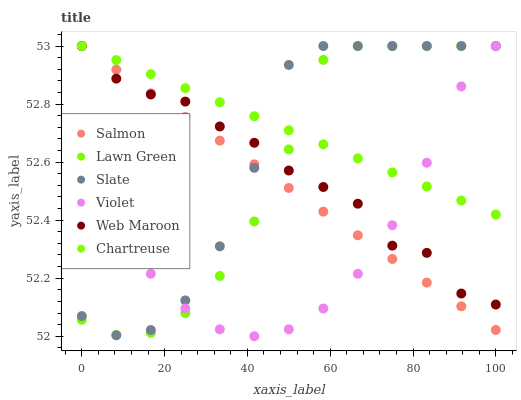Does Violet have the minimum area under the curve?
Answer yes or no. Yes. Does Chartreuse have the maximum area under the curve?
Answer yes or no. Yes. Does Web Maroon have the minimum area under the curve?
Answer yes or no. No. Does Web Maroon have the maximum area under the curve?
Answer yes or no. No. Is Chartreuse the smoothest?
Answer yes or no. Yes. Is Slate the roughest?
Answer yes or no. Yes. Is Web Maroon the smoothest?
Answer yes or no. No. Is Web Maroon the roughest?
Answer yes or no. No. Does Violet have the lowest value?
Answer yes or no. Yes. Does Web Maroon have the lowest value?
Answer yes or no. No. Does Violet have the highest value?
Answer yes or no. Yes. Does Lawn Green intersect Chartreuse?
Answer yes or no. Yes. Is Lawn Green less than Chartreuse?
Answer yes or no. No. Is Lawn Green greater than Chartreuse?
Answer yes or no. No. 